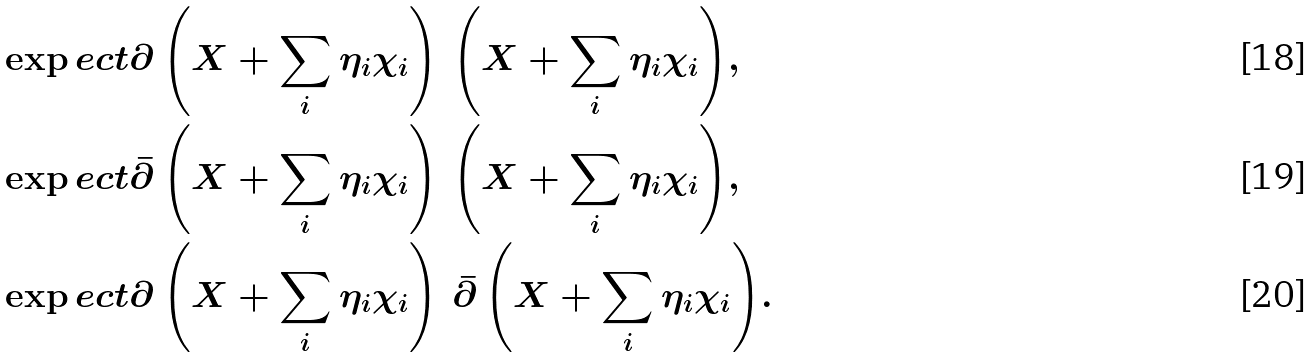<formula> <loc_0><loc_0><loc_500><loc_500>& \exp e c t { \partial \left ( X + \sum _ { i } \eta _ { i } \chi _ { i } \right ) \, \left ( X + \sum _ { i } \eta _ { i } \chi _ { i } \right ) } , \\ & \exp e c t { \bar { \partial } \left ( X + \sum _ { i } \eta _ { i } \chi _ { i } \right ) \, \left ( X + \sum _ { i } \eta _ { i } \chi _ { i } \right ) } , \\ & \exp e c t { \partial \left ( X + \sum _ { i } \eta _ { i } \chi _ { i } \right ) \, \bar { \partial } \left ( X + \sum _ { i } \eta _ { i } \chi _ { i } \right ) } .</formula> 